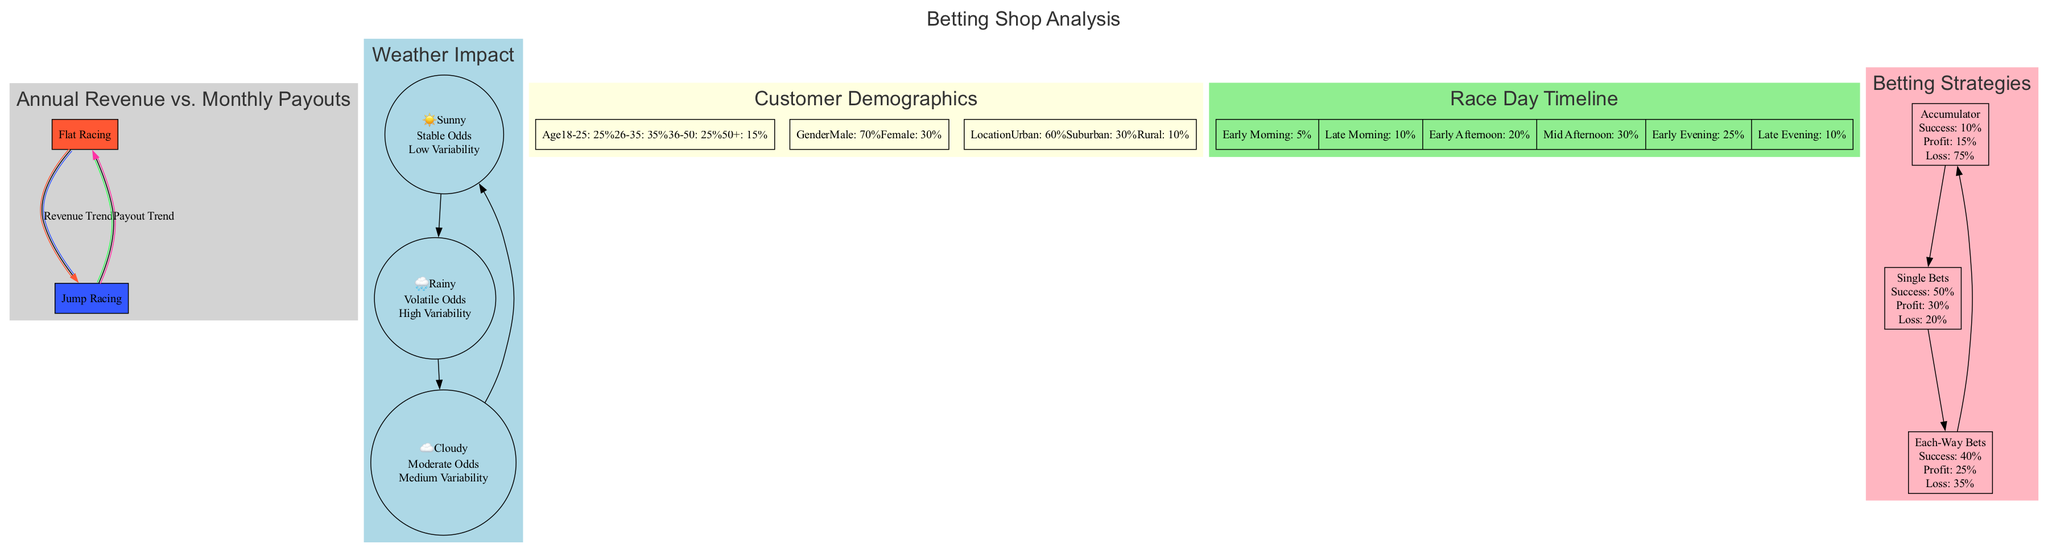What are the annual revenue and monthly payout trend line colors for Flat Racing? The diagram indicates that the Revenue Trend Line for Flat Racing is represented by the color red (#FF5733) and the Payout Trend Line is represented by the color green (#33FF57).
Answer: Red and Green What is the impact of weather condition "Rainy" on betting odds? The diagram shows that the "Rainy" condition has a "Volatile" impact on betting odds and is associated with high variability in race outcomes.
Answer: Volatile How many customer segments are represented in the demographics section? In the demographics section, there are three distinct segments: Age, Gender, and Location, as indicated by the categories provided in the diagram.
Answer: Three What is the maximum percentage of bet placements during the Mid Afternoon timeframe? The timeline shows that the Mid Afternoon (3-6 PM) has the highest percentage of bet placements, reaching 30%.
Answer: 30% Which betting strategy has the highest success rate according to the analysis? The diagram reveals that Single Bets have the highest success rate at 50%, compared to Accumulators and Each-Way Bets.
Answer: 50% How do the outcome variabilities compare among different weather conditions? The diagram categorizes Sunny as Low variability, Cloudy as Medium variability, and Rainy as High variability, indicating a spectrum of unpredictability based on weather conditions.
Answer: Low, Medium, High What is the success rate for the Accumulator betting strategy? According to the diagram, the success rate for the Accumulator betting strategy is 10%, as stated in the flow diagram section.
Answer: 10% Which demographic group has the highest representation in the customer breakdown? The diagram indicates that the 26-35 age group has the highest representation at 35%, compared to the other age categories.
Answer: 35% 